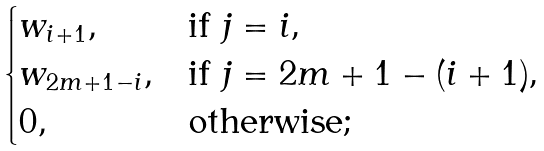Convert formula to latex. <formula><loc_0><loc_0><loc_500><loc_500>\begin{cases} { w } _ { i + 1 } , & \text {if $j=i$,} \\ { w } _ { 2 m + 1 - i } , & \text {if $j=2m+1-(i+1)$,} \\ 0 , & \text {otherwise;} \end{cases}</formula> 